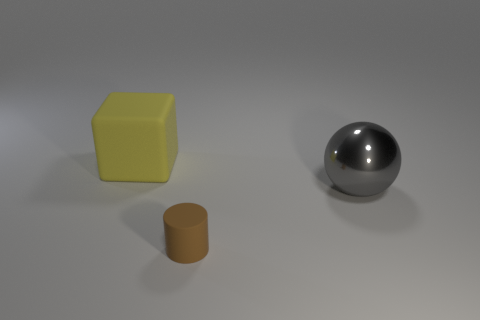Subtract all cylinders. How many objects are left? 2 Subtract all blue spheres. How many red cylinders are left? 0 Add 3 big yellow cubes. How many big yellow cubes are left? 4 Add 1 big spheres. How many big spheres exist? 2 Add 2 big brown balls. How many objects exist? 5 Subtract 1 gray spheres. How many objects are left? 2 Subtract all gray cubes. Subtract all gray cylinders. How many cubes are left? 1 Subtract all blocks. Subtract all big balls. How many objects are left? 1 